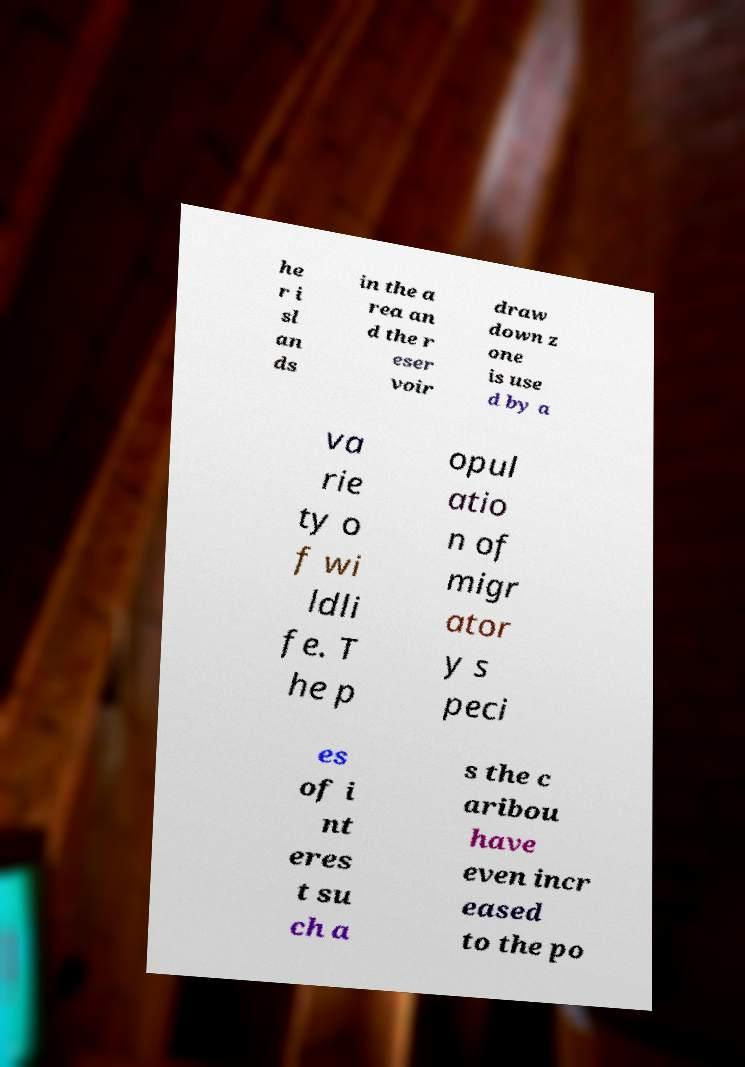For documentation purposes, I need the text within this image transcribed. Could you provide that? he r i sl an ds in the a rea an d the r eser voir draw down z one is use d by a va rie ty o f wi ldli fe. T he p opul atio n of migr ator y s peci es of i nt eres t su ch a s the c aribou have even incr eased to the po 